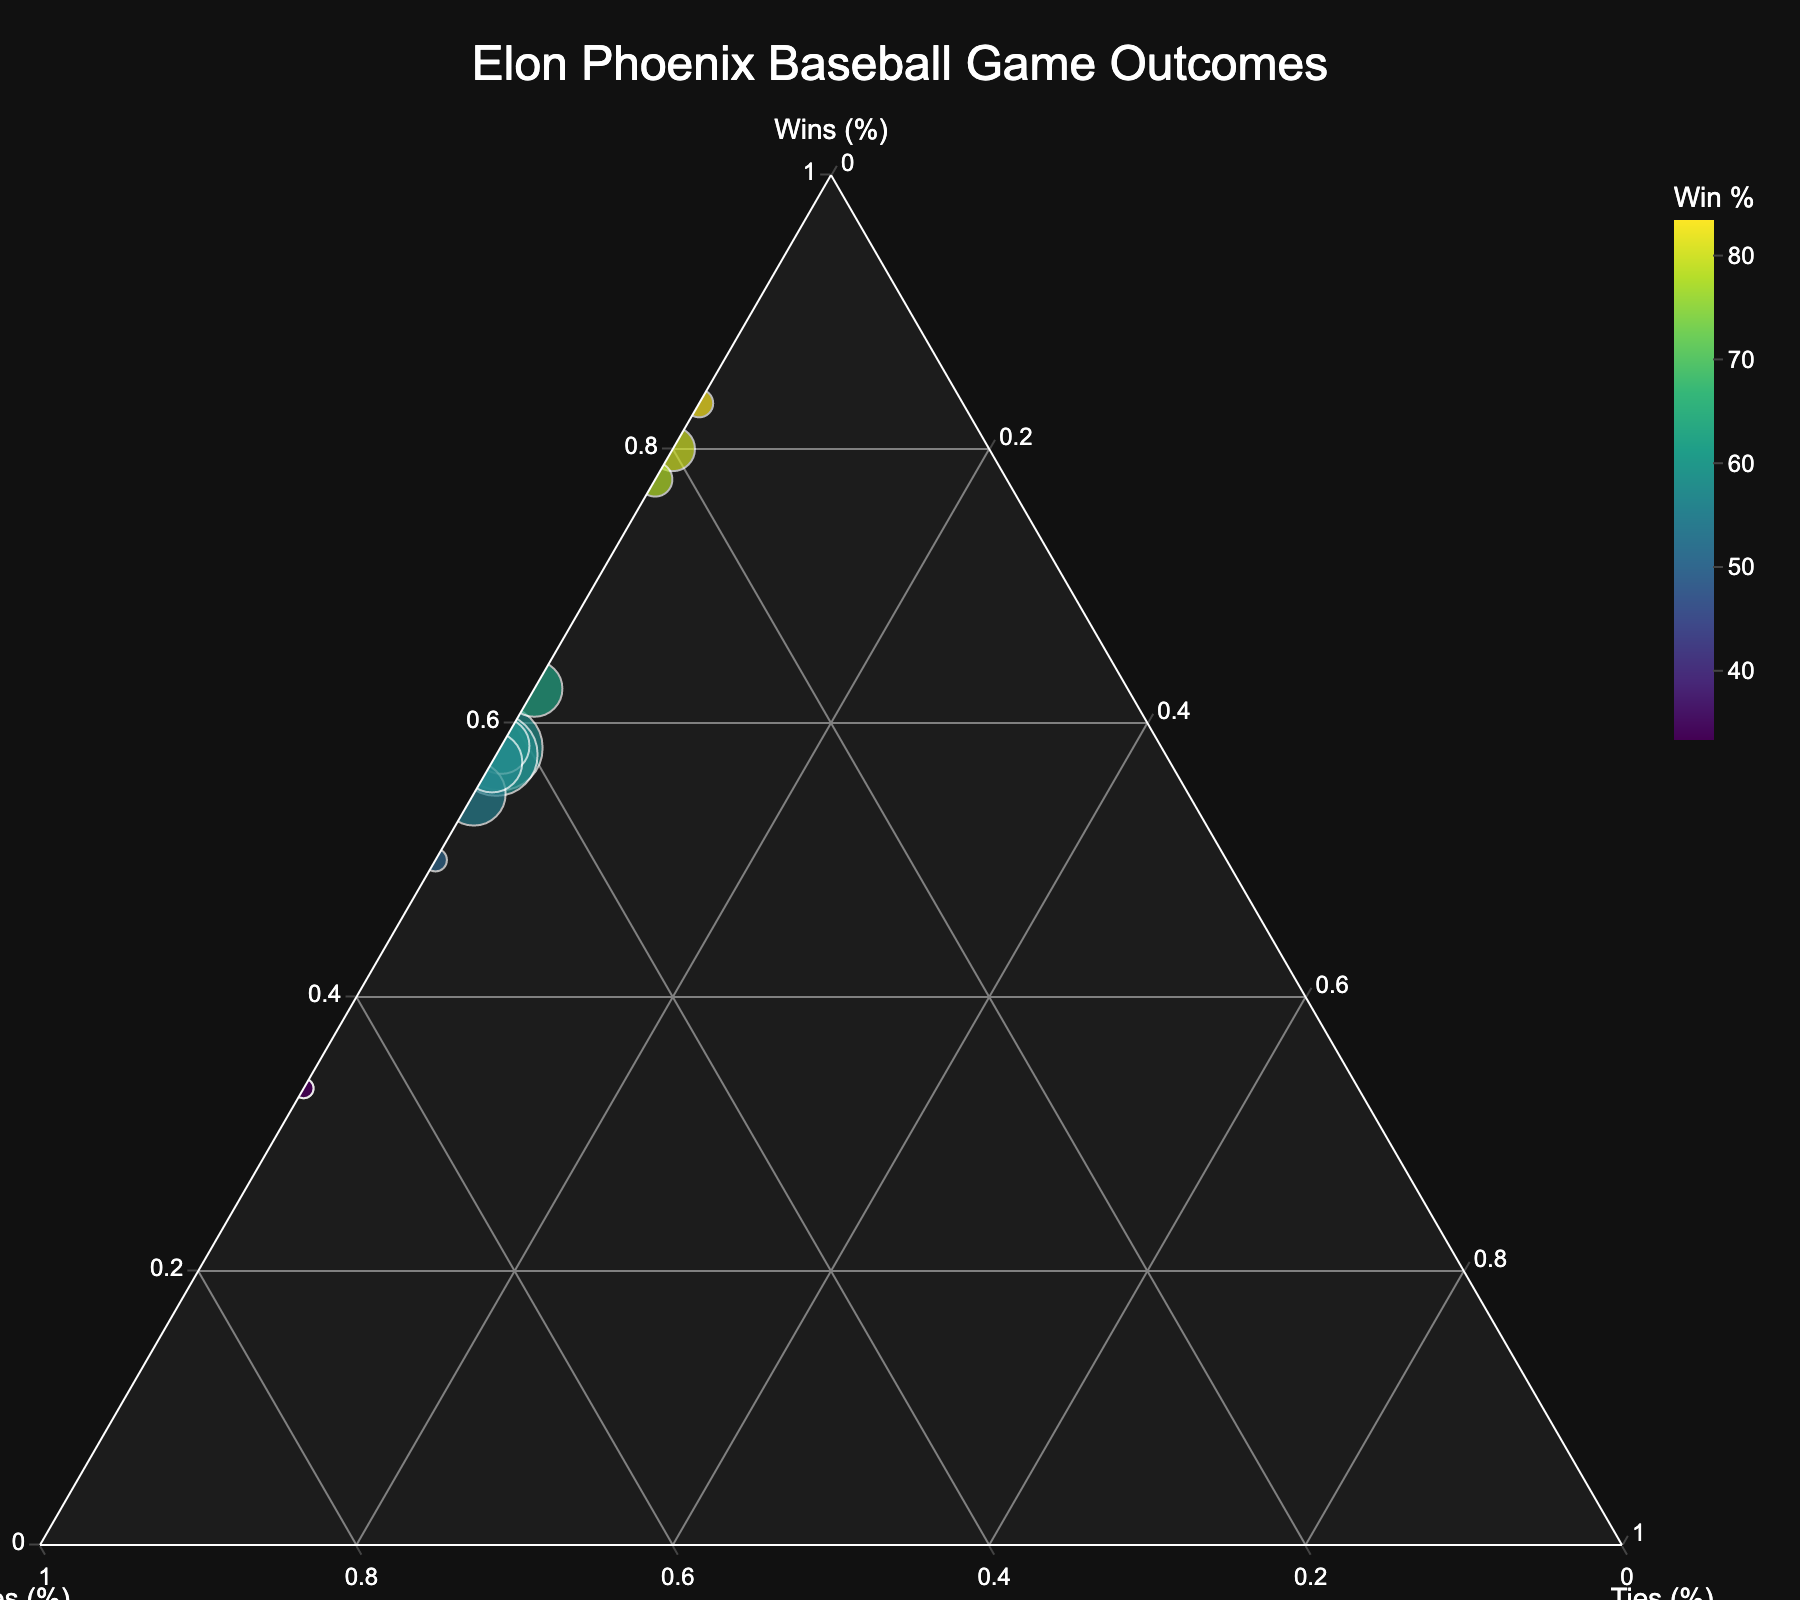How many total game outcomes are represented in the plot? The figure displays different data points, each representing a specific set of game outcomes. Count the number of distinct data points shown in the plot.
Answer: 12 What is the title of this ternary plot? The title is usually displayed prominently at the top of the plot. Look for the largest text in the figure.
Answer: "Elon Phoenix Baseball Game Outcomes" Which outcome has the highest win percentage? Find the data point positioned closest to the "Wins (%)" axis on the ternary plot, which indicates the highest win percentage.
Answer: Regular Season 2020 How does the win percentage of the Colonial Athletic Association 2022 compare to that of the Non-Conference 2021? Identify the data points for Colonial Athletic Association 2022 and Non-Conference 2021. Evaluate their positions relative to the "Wins (%)" axis to compare their win percentages.
Answer: Higher What is the total number of games played in the Southern Conference 2020 season? Locate the data point for the Southern Conference 2020. Check its hover label or size indication for the total number of games.
Answer: 6 Which set of outcomes has the highest loss percentage? Identify the data point closest to the "Losses (%)" axis on the ternary plot, signifying the highest loss percentage.
Answer: NCAA Regionals 2022 How many data points represent seasons with no ties? Examine each data point and check their positions relative to the "Ties (%)" axis. Count those that lie directly on the axis, indicating 0% ties.
Answer: 12 Compare the total number of games played between the Regular Season 2022 and the Colonial Athletic Association 2021. Which has more? Retrieve the total games played from each hover label or size indicator, then compare the two values.
Answer: Regular Season 2022 What is the average win percentage across all outcomes depicted? Calculate each outcome's win percentage, sum them up, and divide by the number of outcomes to get the average win percentage.
Answer: 53.9% 